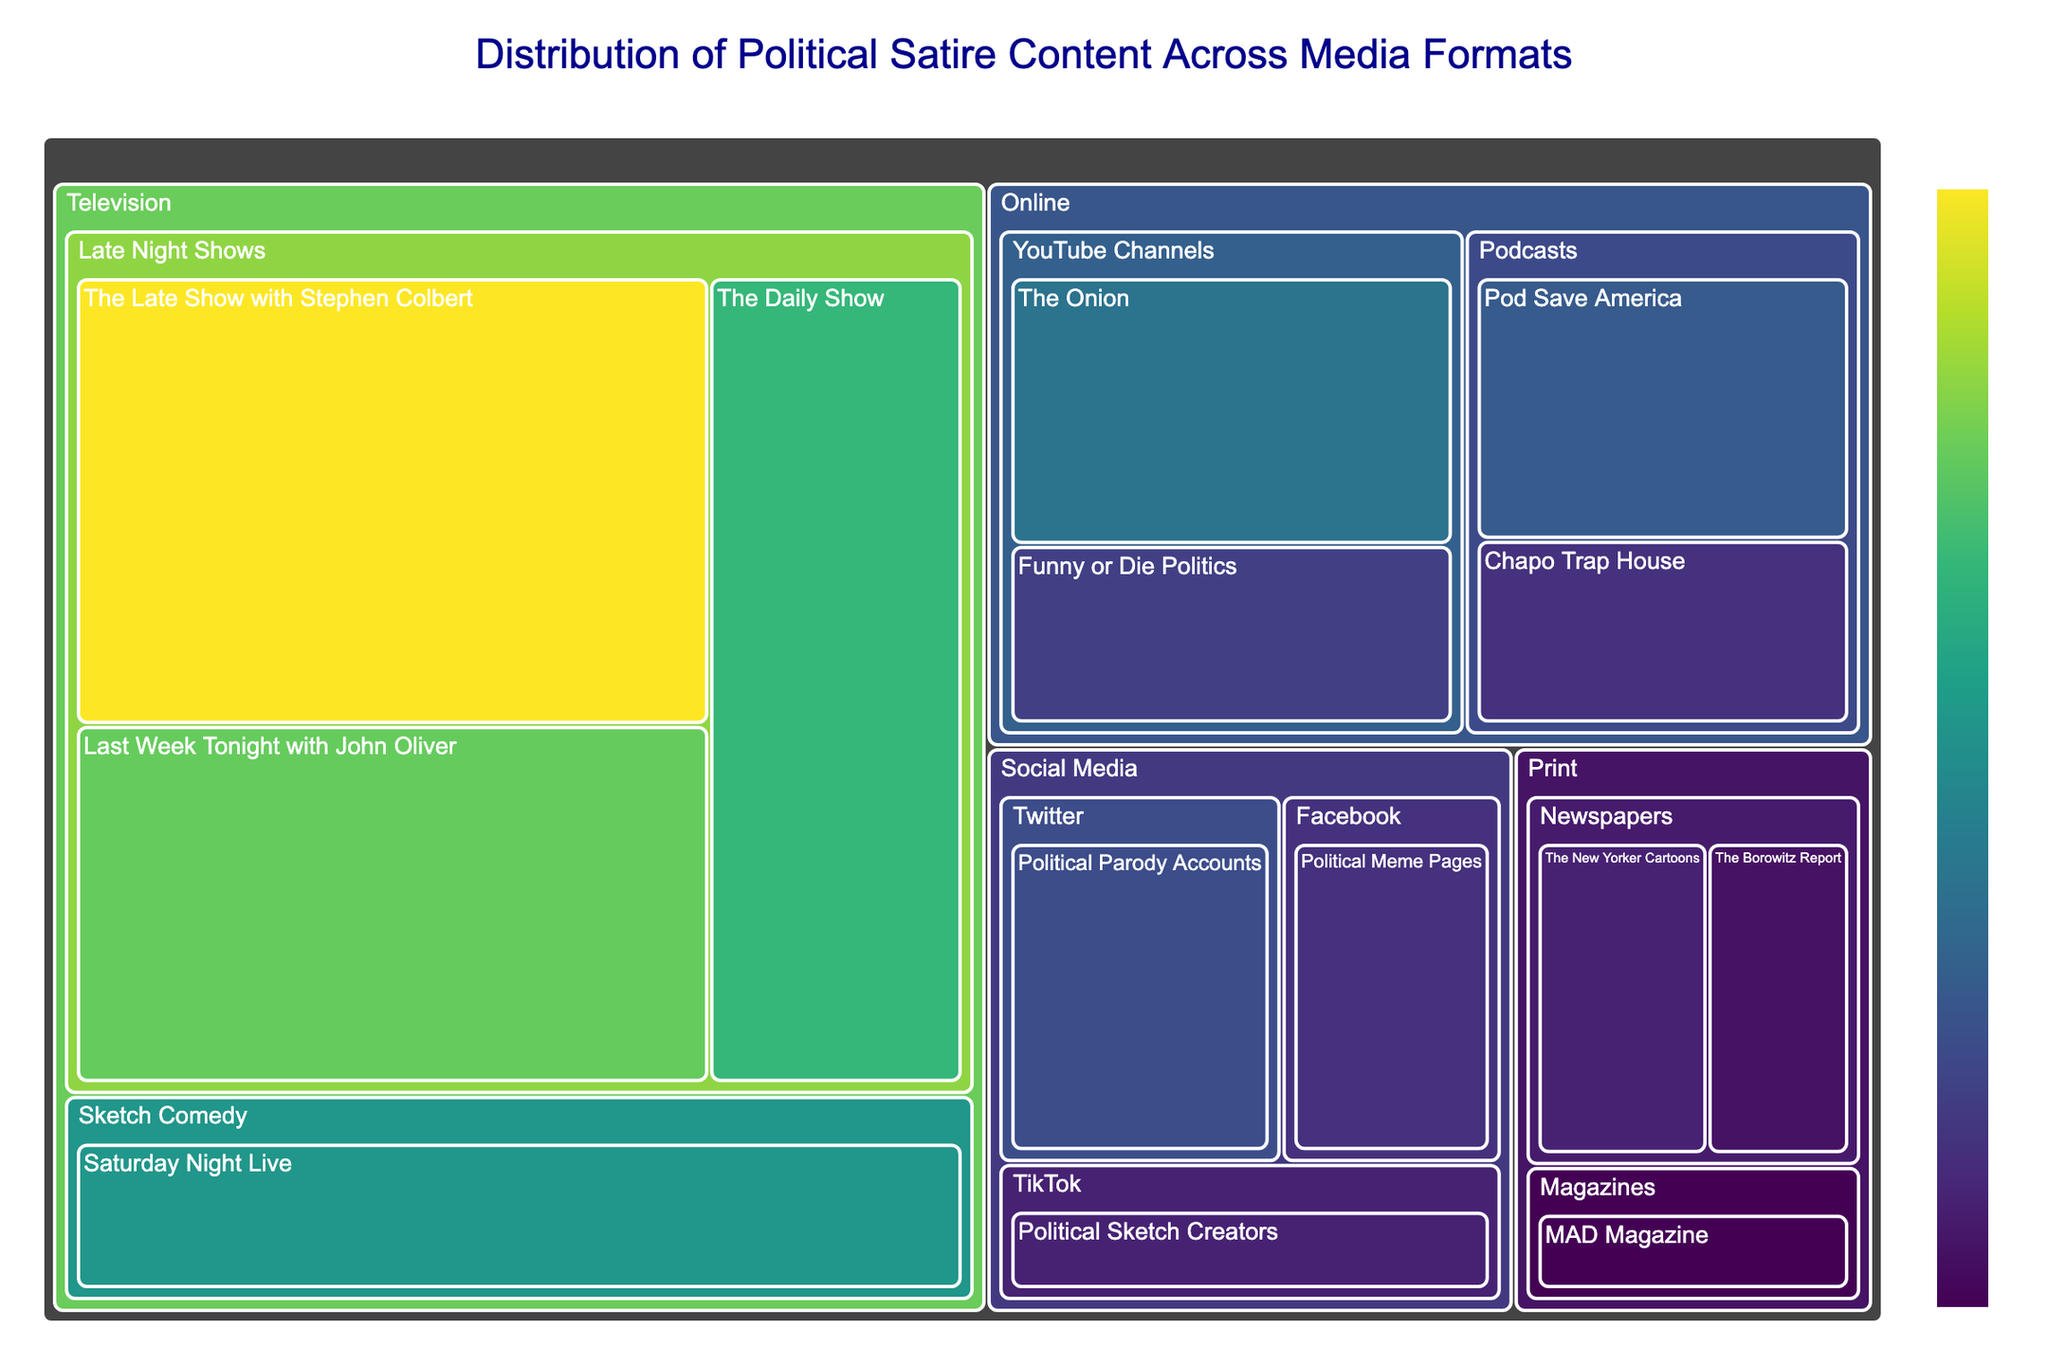What is the title of the figure? The title is usually located at the top of the treemap. It describes what the figure represents.
Answer: Distribution of Political Satire Content Across Media Formats Which format has the highest value in political satire content? The format with the largest box or section would have the highest value.
Answer: Television Among Late Night Shows, which has the highest value? In the Late Night Shows category under Television, identify the subcategory with the largest box.
Answer: The Late Show with Stephen Colbert What is the total value of all political satire content from the Online format? Add the values of all subcategories under the Online format: YouTube Channels, and Podcasts. Online = (The Onion + Funny or Die Politics + Pod Save America + Chapo Trap House) = 12 + 8 + 10 + 7.
Answer: 37 Compare the value of 'MAD Magazine' with 'The Borowitz Report'. Which one has a higher value? Look at the subcategories under Print format and compare the sizes of the boxes for MAD Magazine and The Borowitz Report.
Answer: The Borowitz Report What is the combined value of all Social Media categories? Add the values of the subcategories under Social Media: Political Parody Accounts, Political Meme Pages, and Political Sketch Creators. Social Media = 9 + 7 + 6.
Answer: 22 Which subcategory under Social Media has the lowest value? Identify the smallest box within the Social Media category.
Answer: Political Sketch Creators How does the value of 'Saturday Night Live' compare to 'The Daily Show'? Which one is higher? Compare the values for 'Saturday Night Live' under Sketch Comedy and 'The Daily Show' under Late Night Shows.
Answer: The Daily Show What is the second-largest subcategory under the Television format? Within the Television format, the second-largest box will be the one with the second-highest value.
Answer: Last Week Tonight with John Oliver Calculate the difference in value between the subcategory with the highest value and the subcategory with the lowest value. Identify the highest and lowest values across all subcategories, then subtract the smallest from the largest: 25 (The Late Show with Stephen Colbert) - 4 (MAD Magazine) = 21.
Answer: 21 